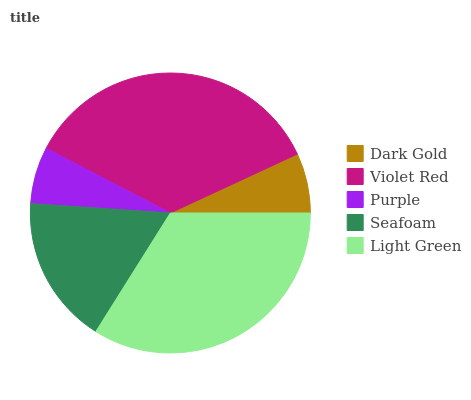Is Purple the minimum?
Answer yes or no. Yes. Is Violet Red the maximum?
Answer yes or no. Yes. Is Violet Red the minimum?
Answer yes or no. No. Is Purple the maximum?
Answer yes or no. No. Is Violet Red greater than Purple?
Answer yes or no. Yes. Is Purple less than Violet Red?
Answer yes or no. Yes. Is Purple greater than Violet Red?
Answer yes or no. No. Is Violet Red less than Purple?
Answer yes or no. No. Is Seafoam the high median?
Answer yes or no. Yes. Is Seafoam the low median?
Answer yes or no. Yes. Is Dark Gold the high median?
Answer yes or no. No. Is Light Green the low median?
Answer yes or no. No. 